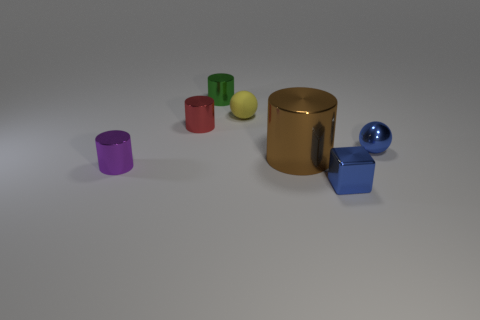There is a tiny metallic thing that is right of the big cylinder and behind the large brown shiny cylinder; what shape is it?
Provide a short and direct response. Sphere. Does the green shiny thing have the same size as the cylinder right of the matte sphere?
Provide a succinct answer. No. What is the color of the other tiny shiny object that is the same shape as the tiny yellow thing?
Provide a succinct answer. Blue. There is a metallic thing on the left side of the tiny red metal thing; is it the same size as the blue metal object that is behind the big brown thing?
Your answer should be compact. Yes. Is the shape of the big brown metal object the same as the small green object?
Offer a very short reply. Yes. How many objects are either yellow spheres in front of the green shiny cylinder or green metallic objects?
Ensure brevity in your answer.  2. Are there any large objects of the same shape as the tiny yellow thing?
Offer a terse response. No. Are there an equal number of blue balls to the left of the small shiny cube and red shiny objects?
Make the answer very short. No. There is a small metal object that is the same color as the block; what shape is it?
Provide a short and direct response. Sphere. What number of cubes have the same size as the yellow rubber thing?
Give a very brief answer. 1. 